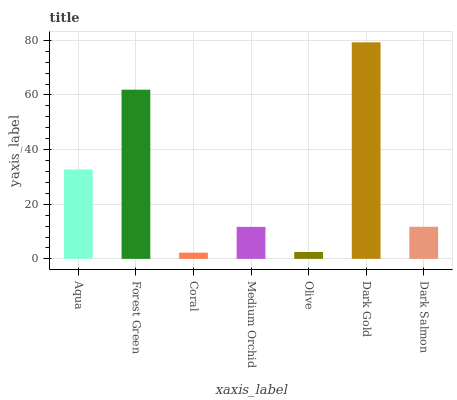Is Coral the minimum?
Answer yes or no. Yes. Is Dark Gold the maximum?
Answer yes or no. Yes. Is Forest Green the minimum?
Answer yes or no. No. Is Forest Green the maximum?
Answer yes or no. No. Is Forest Green greater than Aqua?
Answer yes or no. Yes. Is Aqua less than Forest Green?
Answer yes or no. Yes. Is Aqua greater than Forest Green?
Answer yes or no. No. Is Forest Green less than Aqua?
Answer yes or no. No. Is Dark Salmon the high median?
Answer yes or no. Yes. Is Dark Salmon the low median?
Answer yes or no. Yes. Is Medium Orchid the high median?
Answer yes or no. No. Is Aqua the low median?
Answer yes or no. No. 